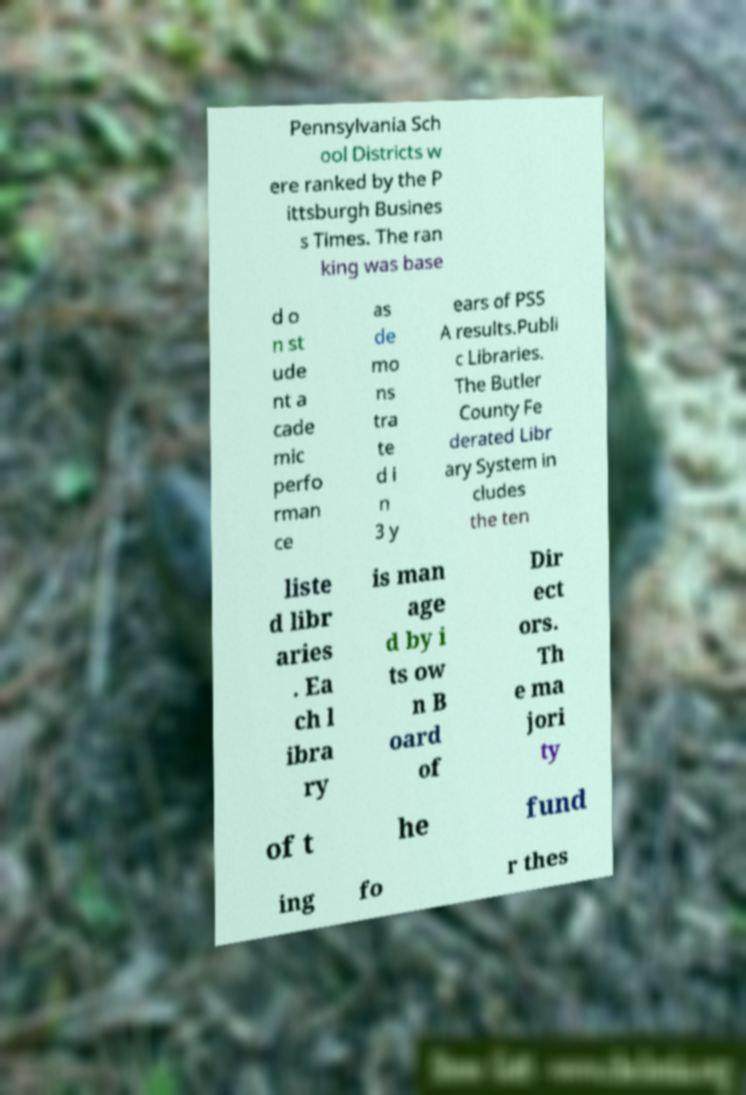I need the written content from this picture converted into text. Can you do that? Pennsylvania Sch ool Districts w ere ranked by the P ittsburgh Busines s Times. The ran king was base d o n st ude nt a cade mic perfo rman ce as de mo ns tra te d i n 3 y ears of PSS A results.Publi c Libraries. The Butler County Fe derated Libr ary System in cludes the ten liste d libr aries . Ea ch l ibra ry is man age d by i ts ow n B oard of Dir ect ors. Th e ma jori ty of t he fund ing fo r thes 